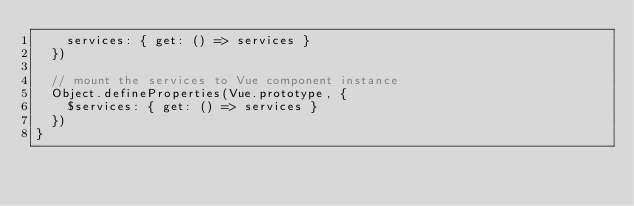<code> <loc_0><loc_0><loc_500><loc_500><_JavaScript_>    services: { get: () => services }
  })

  // mount the services to Vue component instance
  Object.defineProperties(Vue.prototype, {
    $services: { get: () => services }
  })
}
</code> 